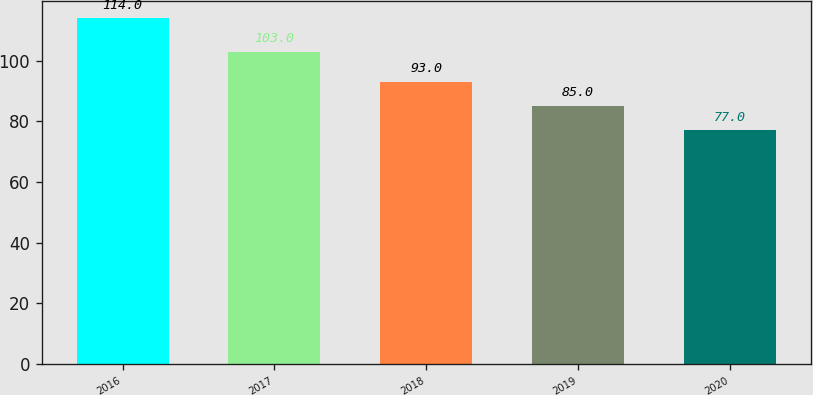Convert chart. <chart><loc_0><loc_0><loc_500><loc_500><bar_chart><fcel>2016<fcel>2017<fcel>2018<fcel>2019<fcel>2020<nl><fcel>114<fcel>103<fcel>93<fcel>85<fcel>77<nl></chart> 